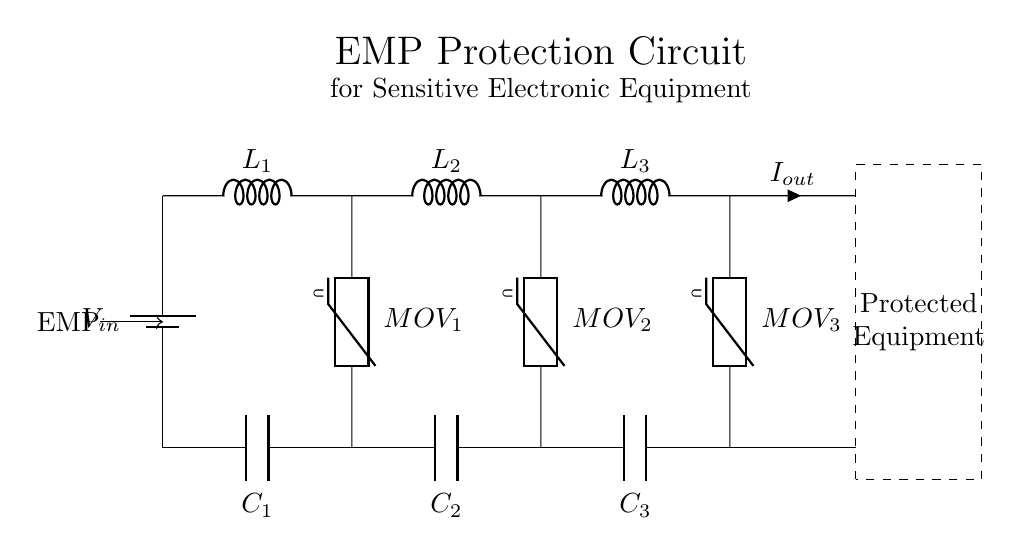What components are used for EMP protection in this circuit? The circuit includes three inductors, three varistors, and three capacitors specifically for EMP protection, which are labeled L1, L2, L3, MOV1, MOV2, MOV3, C1, C2, and C3.
Answer: three inductors, three varistors, three capacitors What is the purpose of the varistors in this circuit? Varistors are used to absorb voltage surges and protect sensitive electronic components from high-voltage transients caused by an EMP. They clamp the voltage and prevent it from exceeding a certain level to safeguard the equipment.
Answer: to absorb voltage surges How many inductors are present in the circuit? The circuit diagram displays three inductors labeled L1, L2, and L3 connected in series after the input voltage source.
Answer: three Which component provides output current to the protected equipment? The output current is indicated by the arrow pointing to the right from the last inductor, which signifies that the current flows toward the protected equipment.
Answer: last inductor How do the inductors and capacitors work together in this circuit? Inductors store energy in a magnetic field when current passes through them, while capacitors store energy in an electric field. Together, they filter out high-frequency noise and transients associated with EMPs, providing a stable output to the connected equipment.
Answer: filter high-frequency noise What is the role of the battery in this circuit? The battery serves as the input voltage source for the circuit, supplying power that will be protected by the EMP protection components.
Answer: input voltage source How many pathways are utilized for the flow of current from the input to the output? There are three pathways formed by the inductors, with each inductor having two connections: one leading to the next component and the other leading to the output, resulting in a single path that traverses through all components.
Answer: one pathway 